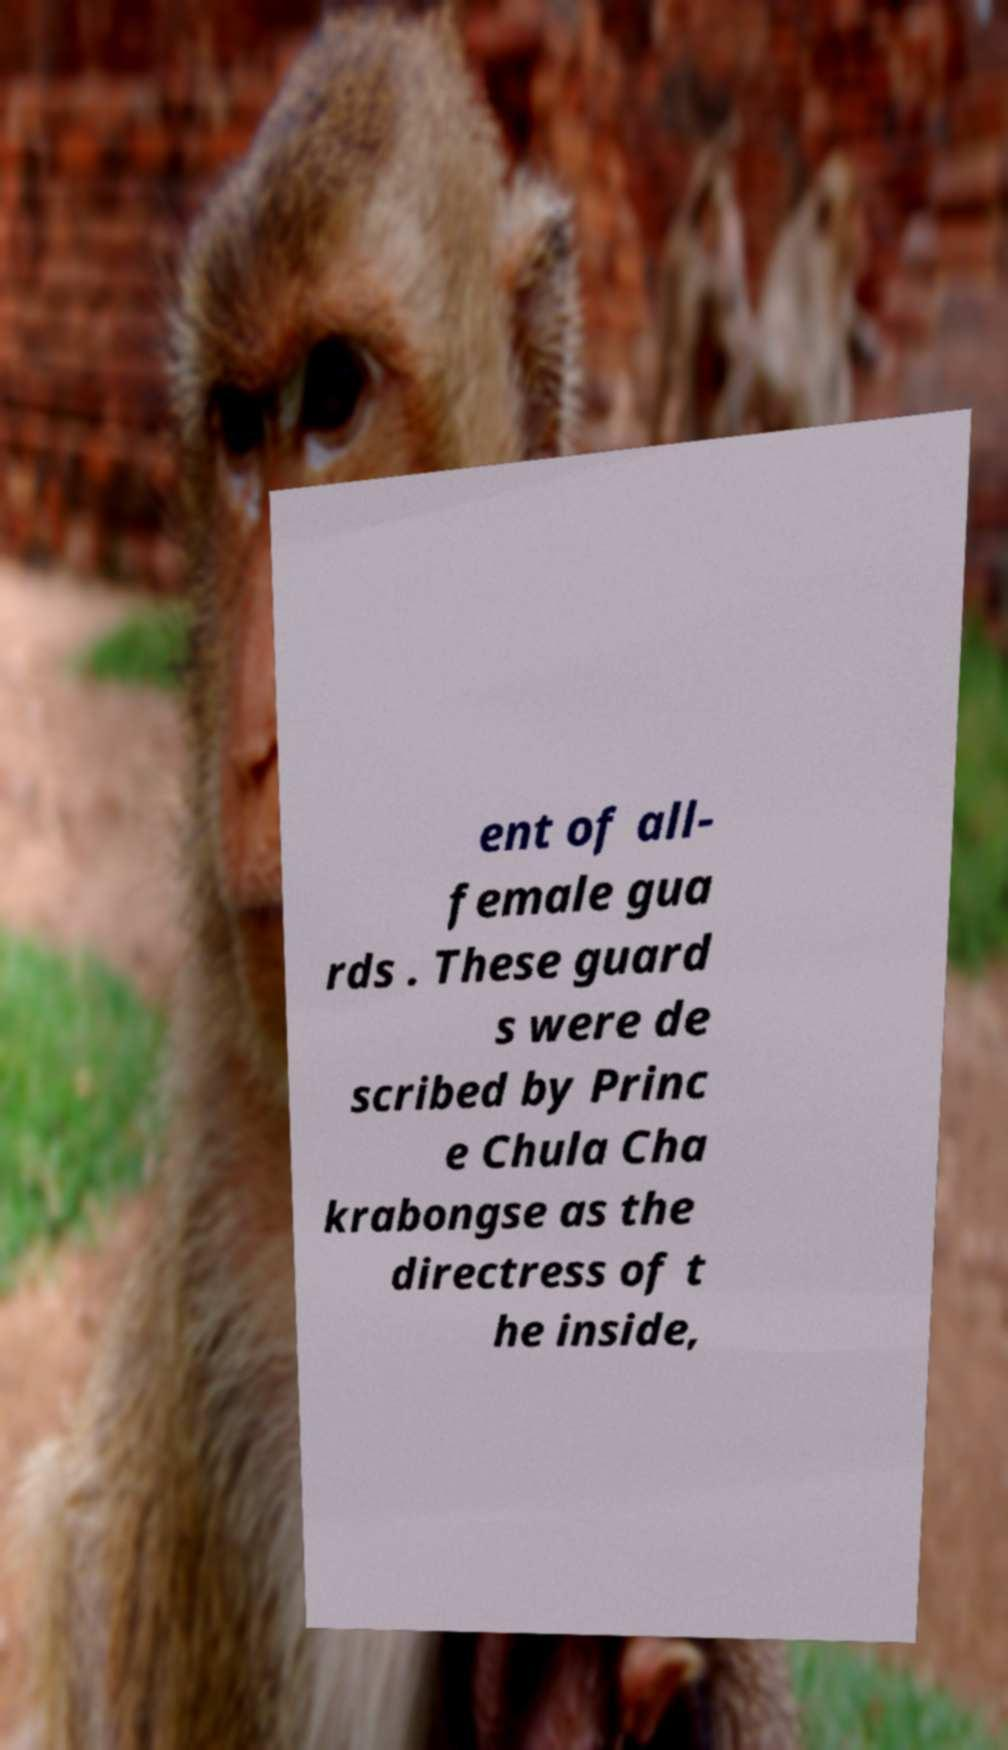I need the written content from this picture converted into text. Can you do that? ent of all- female gua rds . These guard s were de scribed by Princ e Chula Cha krabongse as the directress of t he inside, 